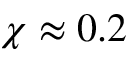<formula> <loc_0><loc_0><loc_500><loc_500>\chi \approx 0 . 2</formula> 